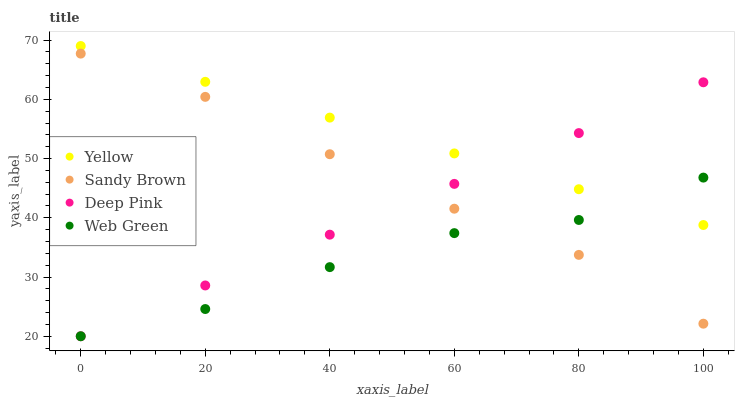Does Web Green have the minimum area under the curve?
Answer yes or no. Yes. Does Yellow have the maximum area under the curve?
Answer yes or no. Yes. Does Sandy Brown have the minimum area under the curve?
Answer yes or no. No. Does Sandy Brown have the maximum area under the curve?
Answer yes or no. No. Is Deep Pink the smoothest?
Answer yes or no. Yes. Is Web Green the roughest?
Answer yes or no. Yes. Is Sandy Brown the smoothest?
Answer yes or no. No. Is Sandy Brown the roughest?
Answer yes or no. No. Does Deep Pink have the lowest value?
Answer yes or no. Yes. Does Sandy Brown have the lowest value?
Answer yes or no. No. Does Yellow have the highest value?
Answer yes or no. Yes. Does Sandy Brown have the highest value?
Answer yes or no. No. Is Sandy Brown less than Yellow?
Answer yes or no. Yes. Is Yellow greater than Sandy Brown?
Answer yes or no. Yes. Does Sandy Brown intersect Web Green?
Answer yes or no. Yes. Is Sandy Brown less than Web Green?
Answer yes or no. No. Is Sandy Brown greater than Web Green?
Answer yes or no. No. Does Sandy Brown intersect Yellow?
Answer yes or no. No. 